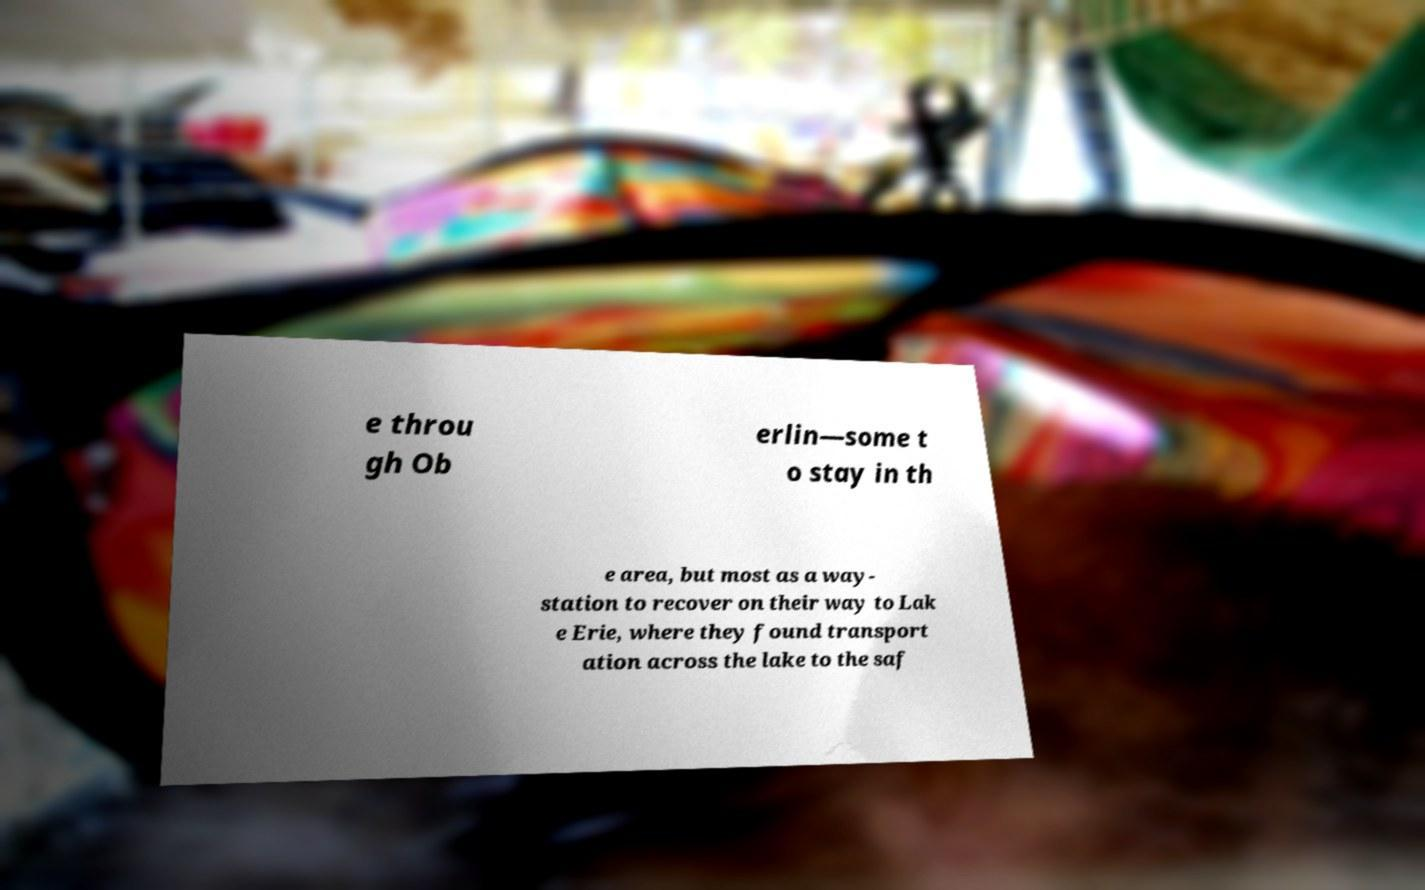Can you accurately transcribe the text from the provided image for me? e throu gh Ob erlin—some t o stay in th e area, but most as a way- station to recover on their way to Lak e Erie, where they found transport ation across the lake to the saf 